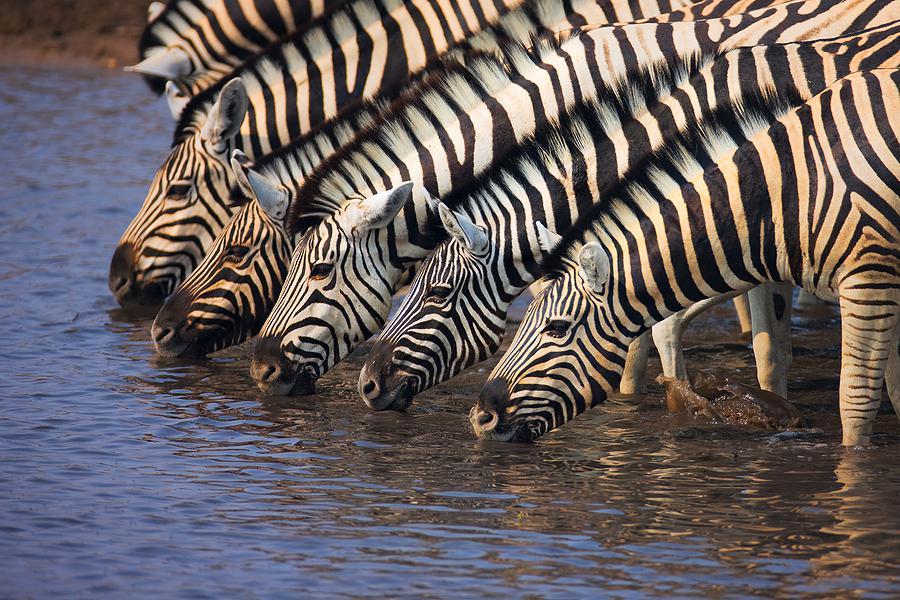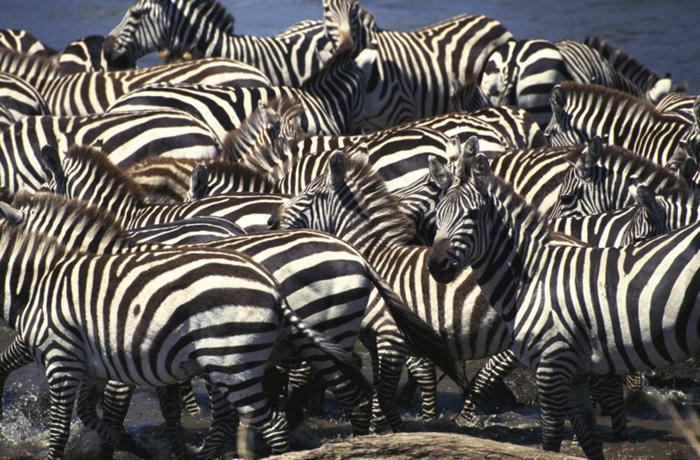The first image is the image on the left, the second image is the image on the right. Assess this claim about the two images: "The zebras in one of the images are drinking from a body of water.". Correct or not? Answer yes or no. Yes. The first image is the image on the left, the second image is the image on the right. Assess this claim about the two images: "One image shows zebras with necks extending from the right lined up to drink, with heads bent to the water.". Correct or not? Answer yes or no. Yes. 